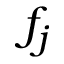<formula> <loc_0><loc_0><loc_500><loc_500>f _ { j }</formula> 